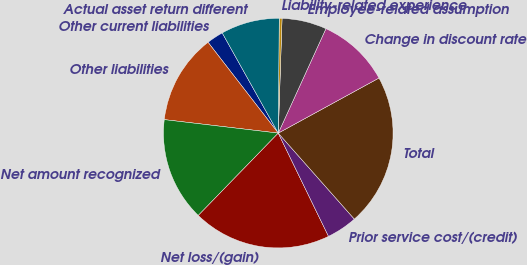<chart> <loc_0><loc_0><loc_500><loc_500><pie_chart><fcel>Other current liabilities<fcel>Other liabilities<fcel>Net amount recognized<fcel>Net loss/(gain)<fcel>Prior service cost/(credit)<fcel>Total<fcel>Change in discount rate<fcel>Employee-related assumption<fcel>Liability-related experience<fcel>Actual asset return different<nl><fcel>2.36%<fcel>12.65%<fcel>14.61%<fcel>19.48%<fcel>4.32%<fcel>21.44%<fcel>10.22%<fcel>6.29%<fcel>0.39%<fcel>8.25%<nl></chart> 